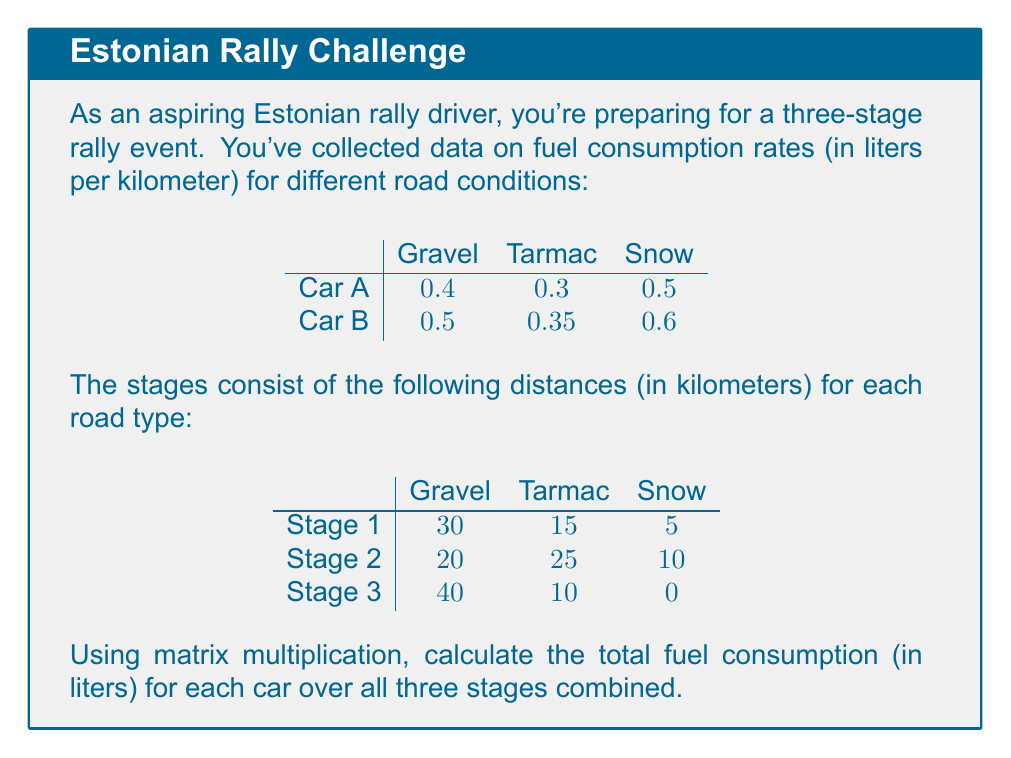Show me your answer to this math problem. Let's approach this step-by-step:

1) First, we need to set up our matrices. Let's call the fuel consumption rate matrix $R$ and the stage distance matrix $D$:

   $$R = \begin{bmatrix}
   0.4 & 0.3 & 0.5 \\
   0.5 & 0.35 & 0.6
   \end{bmatrix}$$

   $$D = \begin{bmatrix}
   30 & 15 & 5 \\
   20 & 25 & 10 \\
   40 & 10 & 0
   \end{bmatrix}$$

2) To get the total fuel consumption, we need to multiply $R$ by $D$. This will give us a 2x3 matrix where each element represents the fuel consumption for a car on a specific stage.

3) The matrix multiplication is performed as follows:

   $$RD = \begin{bmatrix}
   (0.4 \cdot 30 + 0.3 \cdot 15 + 0.5 \cdot 5) & (0.4 \cdot 20 + 0.3 \cdot 25 + 0.5 \cdot 10) & (0.4 \cdot 40 + 0.3 \cdot 10 + 0.5 \cdot 0) \\
   (0.5 \cdot 30 + 0.35 \cdot 15 + 0.6 \cdot 5) & (0.5 \cdot 20 + 0.35 \cdot 25 + 0.6 \cdot 10) & (0.5 \cdot 40 + 0.35 \cdot 10 + 0.6 \cdot 0)
   \end{bmatrix}$$

4) Let's calculate each element:

   $$RD = \begin{bmatrix}
   17.5 & 20.5 & 19 \\
   22 & 25.75 & 23.5
   \end{bmatrix}$$

5) To get the total fuel consumption for each car, we sum across the rows:

   Car A: $17.5 + 20.5 + 19 = 57$ liters
   Car B: $22 + 25.75 + 23.5 = 71.25$ liters

Therefore, Car A will consume 57 liters and Car B will consume 71.25 liters over all three stages.
Answer: Car A: 57 liters, Car B: 71.25 liters 